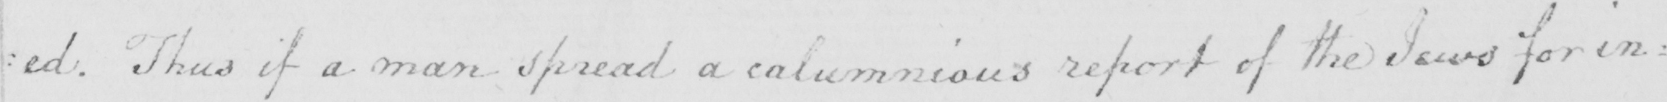Please provide the text content of this handwritten line. : ed . Thus if a man spread a calumnious report of the Jews for in= 